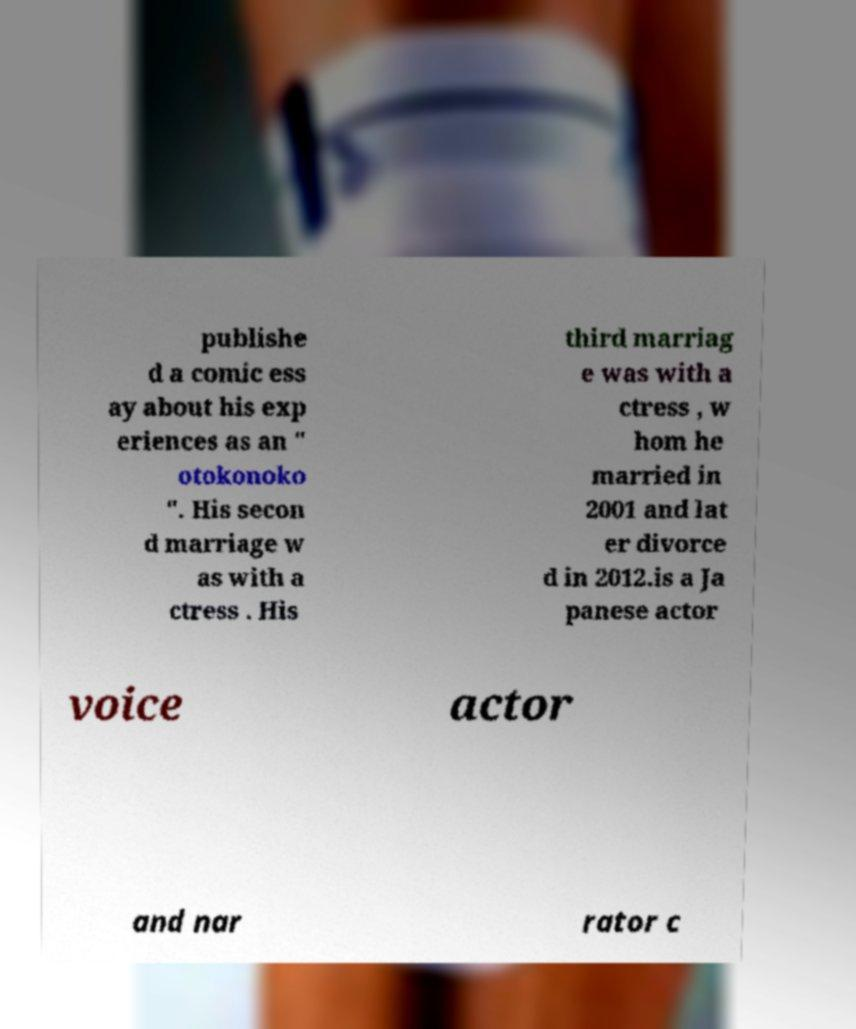I need the written content from this picture converted into text. Can you do that? publishe d a comic ess ay about his exp eriences as an " otokonoko ". His secon d marriage w as with a ctress . His third marriag e was with a ctress , w hom he married in 2001 and lat er divorce d in 2012.is a Ja panese actor voice actor and nar rator c 